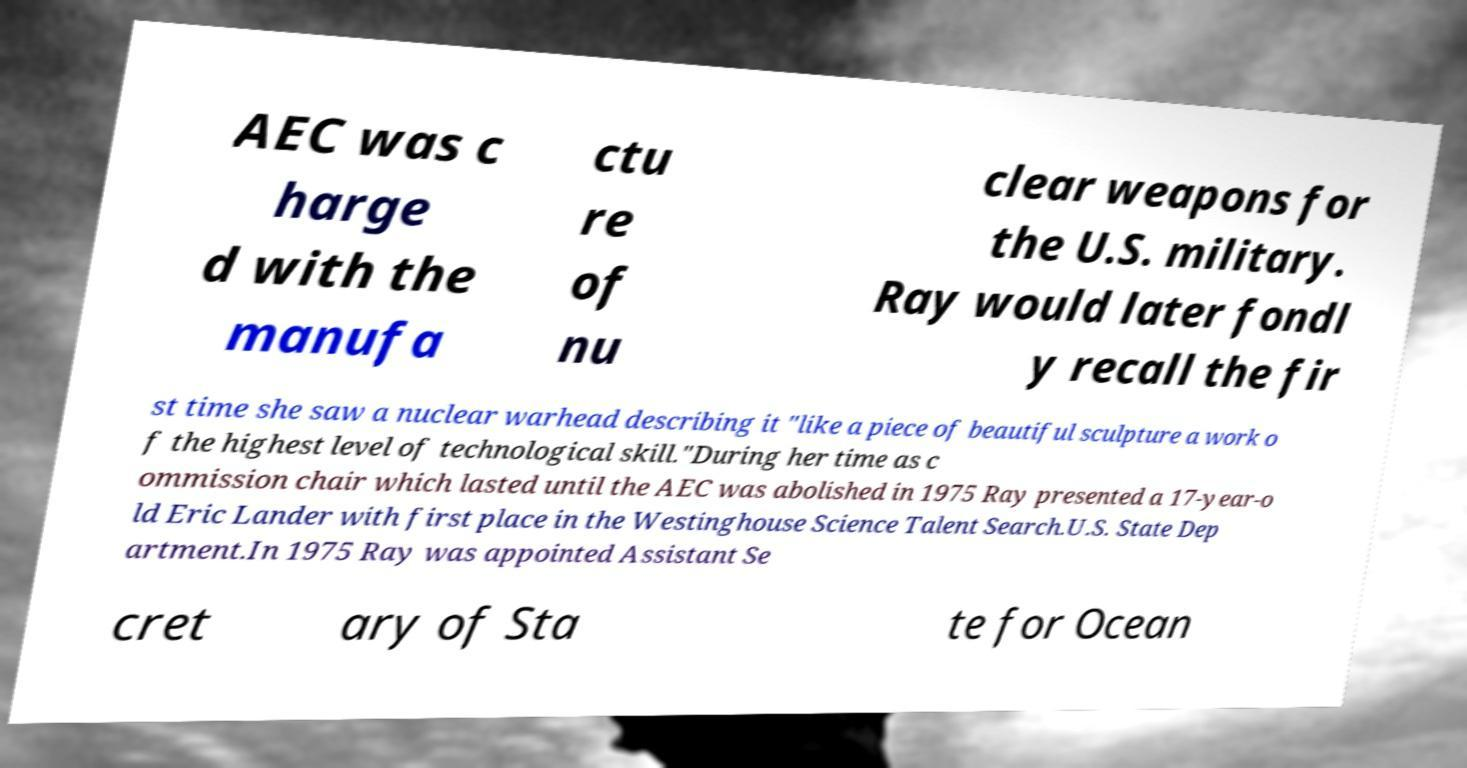What messages or text are displayed in this image? I need them in a readable, typed format. AEC was c harge d with the manufa ctu re of nu clear weapons for the U.S. military. Ray would later fondl y recall the fir st time she saw a nuclear warhead describing it "like a piece of beautiful sculpture a work o f the highest level of technological skill."During her time as c ommission chair which lasted until the AEC was abolished in 1975 Ray presented a 17-year-o ld Eric Lander with first place in the Westinghouse Science Talent Search.U.S. State Dep artment.In 1975 Ray was appointed Assistant Se cret ary of Sta te for Ocean 